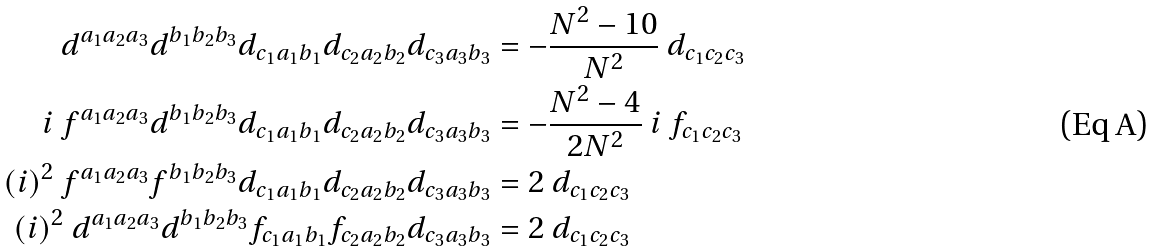Convert formula to latex. <formula><loc_0><loc_0><loc_500><loc_500>d ^ { a _ { 1 } a _ { 2 } a _ { 3 } } d ^ { b _ { 1 } b _ { 2 } b _ { 3 } } d _ { c _ { 1 } a _ { 1 } b _ { 1 } } d _ { c _ { 2 } a _ { 2 } b _ { 2 } } d _ { c _ { 3 } a _ { 3 } b _ { 3 } } & = - \frac { N ^ { 2 } - 1 0 } { N ^ { 2 } } \ d _ { c _ { 1 } c _ { 2 } c _ { 3 } } \\ i \ f ^ { a _ { 1 } a _ { 2 } a _ { 3 } } d ^ { b _ { 1 } b _ { 2 } b _ { 3 } } d _ { c _ { 1 } a _ { 1 } b _ { 1 } } d _ { c _ { 2 } a _ { 2 } b _ { 2 } } d _ { c _ { 3 } a _ { 3 } b _ { 3 } } & = - \frac { N ^ { 2 } - 4 } { 2 N ^ { 2 } } \ i \ f _ { c _ { 1 } c _ { 2 } c _ { 3 } } \\ ( i ) ^ { 2 } \ f ^ { a _ { 1 } a _ { 2 } a _ { 3 } } f ^ { b _ { 1 } b _ { 2 } b _ { 3 } } d _ { c _ { 1 } a _ { 1 } b _ { 1 } } d _ { c _ { 2 } a _ { 2 } b _ { 2 } } d _ { c _ { 3 } a _ { 3 } b _ { 3 } } & = 2 \ d _ { c _ { 1 } c _ { 2 } c _ { 3 } } \\ ( i ) ^ { 2 } \ d ^ { a _ { 1 } a _ { 2 } a _ { 3 } } d ^ { b _ { 1 } b _ { 2 } b _ { 3 } } f _ { c _ { 1 } a _ { 1 } b _ { 1 } } f _ { c _ { 2 } a _ { 2 } b _ { 2 } } d _ { c _ { 3 } a _ { 3 } b _ { 3 } } & = 2 \ d _ { c _ { 1 } c _ { 2 } c _ { 3 } }</formula> 